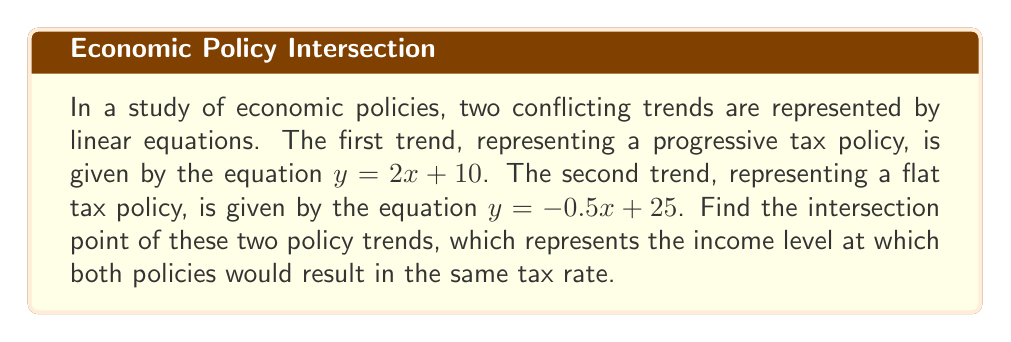What is the answer to this math problem? To find the intersection point of two lines, we need to solve the system of equations:

1) $y = 2x + 10$
2) $y = -0.5x + 25$

Step 1: Set the equations equal to each other since y is the same at the intersection point.
$2x + 10 = -0.5x + 25$

Step 2: Solve for x by isolating variables on one side and constants on the other.
$2x + 0.5x = 25 - 10$
$2.5x = 15$

Step 3: Divide both sides by 2.5 to solve for x.
$x = 15 / 2.5 = 6$

Step 4: Substitute this x-value into either of the original equations to find y. Let's use the first equation:
$y = 2(6) + 10 = 12 + 10 = 22$

Therefore, the intersection point is (6, 22).

[asy]
import graph;
size(200);
xaxis("x", -2, 10, arrow=Arrow);
yaxis("y", 0, 30, arrow=Arrow);
draw((0,10)--(10,30), blue);
draw((0,25)--(10,20), red);
dot((6,22));
label("(6, 22)", (6,22), NE);
label("y = 2x + 10", (8,26), N, blue);
label("y = -0.5x + 25", (8,18), S, red);
[/asy]
Answer: (6, 22) 